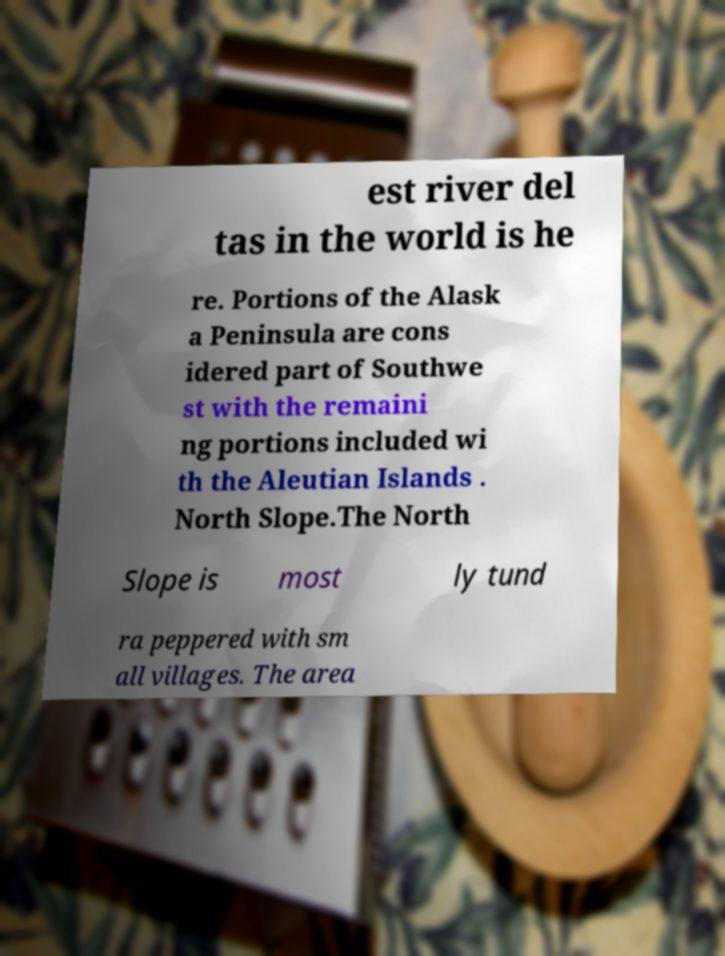For documentation purposes, I need the text within this image transcribed. Could you provide that? est river del tas in the world is he re. Portions of the Alask a Peninsula are cons idered part of Southwe st with the remaini ng portions included wi th the Aleutian Islands . North Slope.The North Slope is most ly tund ra peppered with sm all villages. The area 